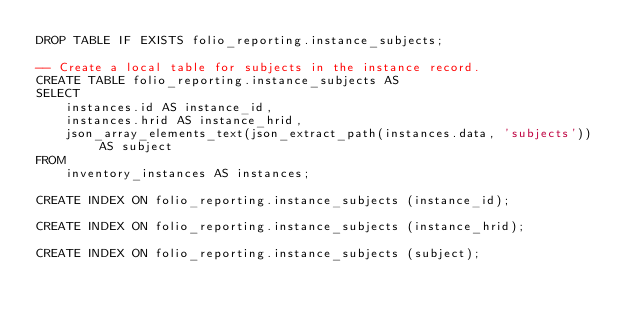<code> <loc_0><loc_0><loc_500><loc_500><_SQL_>DROP TABLE IF EXISTS folio_reporting.instance_subjects;

-- Create a local table for subjects in the instance record.
CREATE TABLE folio_reporting.instance_subjects AS
SELECT
    instances.id AS instance_id,
    instances.hrid AS instance_hrid,
    json_array_elements_text(json_extract_path(instances.data, 'subjects')) AS subject
FROM
    inventory_instances AS instances;

CREATE INDEX ON folio_reporting.instance_subjects (instance_id);

CREATE INDEX ON folio_reporting.instance_subjects (instance_hrid);

CREATE INDEX ON folio_reporting.instance_subjects (subject);

</code> 